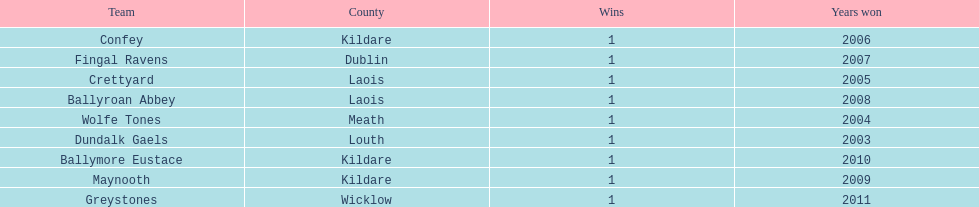Which team was the previous winner before ballyroan abbey in 2008? Fingal Ravens. 